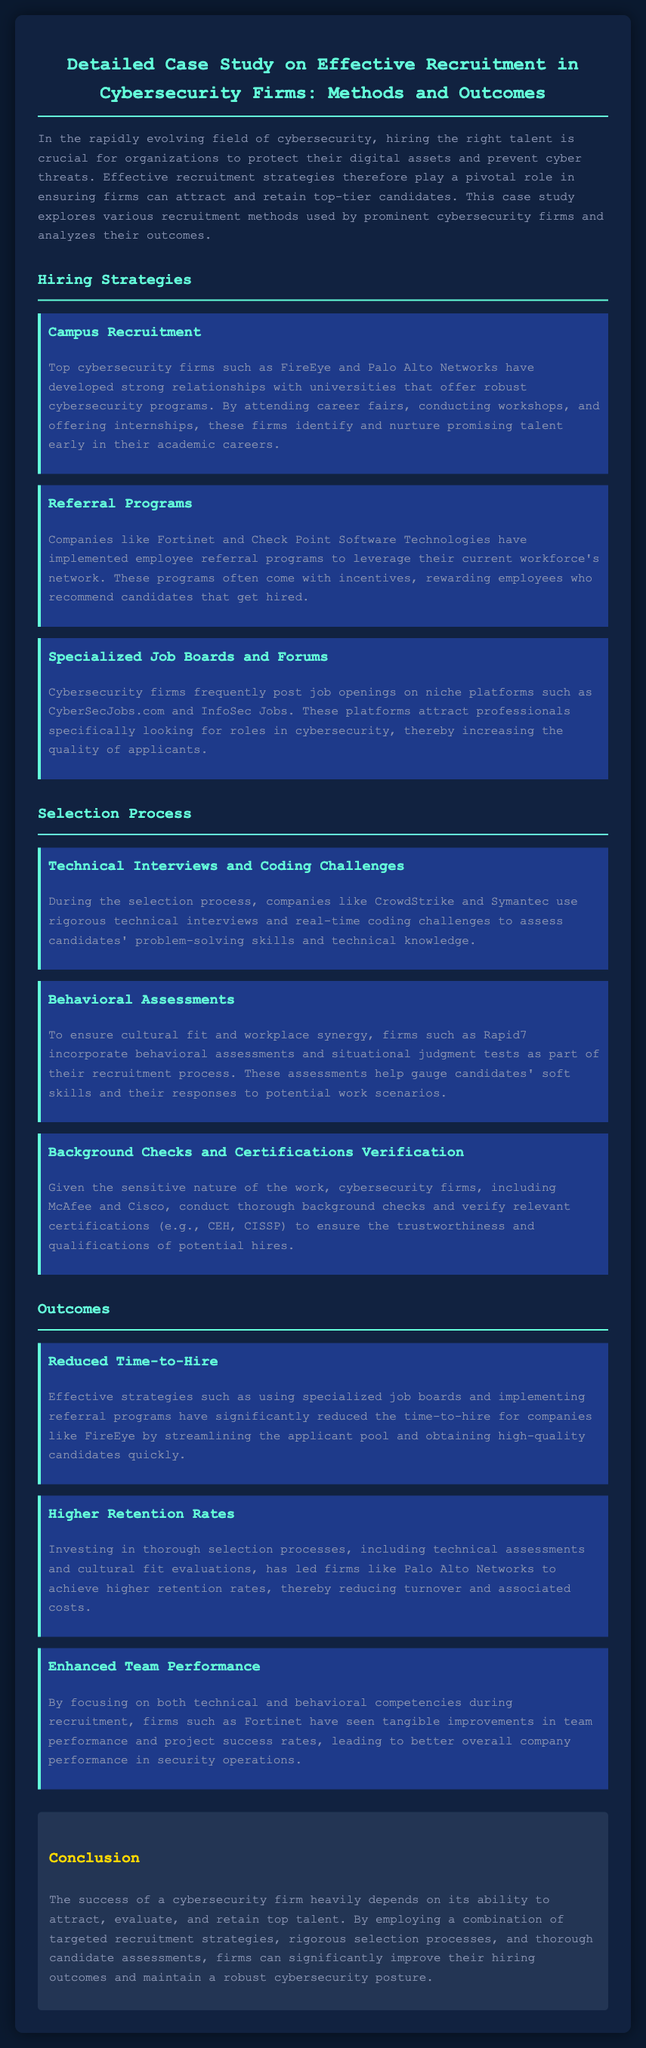What are the names of two firms that utilize campus recruitment? The document lists FireEye and Palo Alto Networks as firms that use campus recruitment strategies.
Answer: FireEye, Palo Alto Networks What recruitment method leverages employee networks? The document describes employee referral programs as a method that utilizes the networks of current employees.
Answer: Referral Programs Which platforms are mentioned as specialized job boards for cybersecurity? CyberSecJobs.com and InfoSec Jobs are specifically highlighted as platforms for job postings.
Answer: CyberSecJobs.com, InfoSec Jobs What type of assessment helps gauge candidates' soft skills? The document mentions behavioral assessments and situational judgment tests as tools for evaluating soft skills.
Answer: Behavioral Assessments Which company has experienced a significant reduction in time-to-hire? FireEye is indicated in the document as a company that has reduced its time-to-hire by using effective strategies.
Answer: FireEye What was one outcome of investing in thorough selection processes? The document states that investing in thorough selection processes has led to higher retention rates.
Answer: Higher Retention Rates What is a key factor for the success of cybersecurity firms according to the conclusion? The conclusion emphasizes the importance of attracting, evaluating, and retaining top talent in cybersecurity firms.
Answer: Attracting, evaluating, and retaining top talent Which firm is noted for achieving enhanced team performance? Fortinet is specifically mentioned as having improved team performance through focused recruitment strategies.
Answer: Fortinet What does the document say about verifying candidate qualifications? It mentions that firms conduct thorough background checks and verify relevant certifications.
Answer: Background Checks and Certifications Verification 